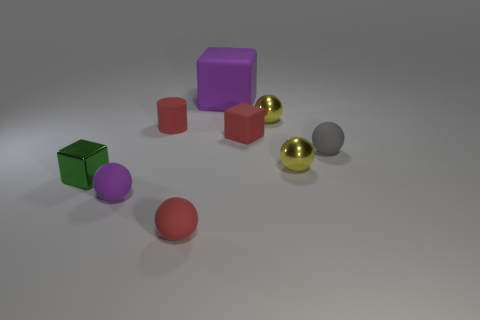Are there any other things that have the same size as the purple matte cube?
Ensure brevity in your answer.  No. The gray rubber object is what shape?
Your response must be concise. Sphere. Are there an equal number of purple matte blocks in front of the small cylinder and red rubber cylinders?
Provide a short and direct response. No. Is there any other thing that is the same material as the big purple block?
Your answer should be compact. Yes. Are the cube that is left of the big thing and the large cube made of the same material?
Offer a terse response. No. Are there fewer purple rubber objects that are in front of the green block than big yellow metal things?
Provide a short and direct response. No. How many shiny things are either red balls or tiny brown cubes?
Provide a short and direct response. 0. Is the color of the tiny cylinder the same as the large matte cube?
Keep it short and to the point. No. Are there any other things that are the same color as the small shiny cube?
Offer a very short reply. No. Does the yellow thing in front of the gray sphere have the same shape as the purple object that is in front of the tiny gray ball?
Offer a terse response. Yes. 